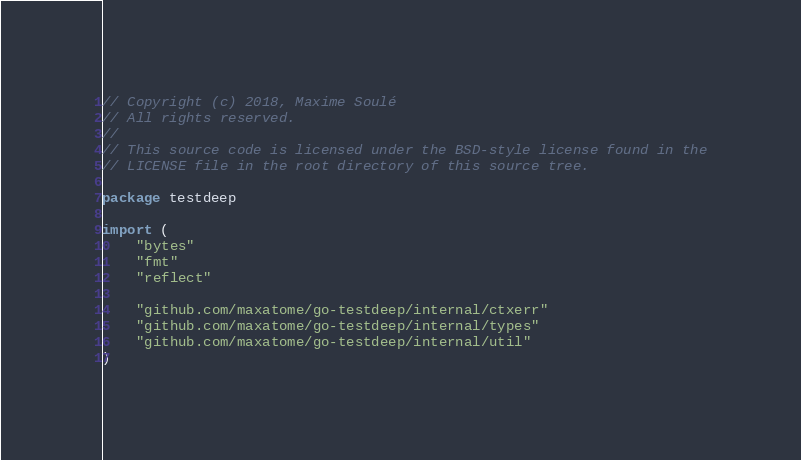<code> <loc_0><loc_0><loc_500><loc_500><_Go_>// Copyright (c) 2018, Maxime Soulé
// All rights reserved.
//
// This source code is licensed under the BSD-style license found in the
// LICENSE file in the root directory of this source tree.

package testdeep

import (
	"bytes"
	"fmt"
	"reflect"

	"github.com/maxatome/go-testdeep/internal/ctxerr"
	"github.com/maxatome/go-testdeep/internal/types"
	"github.com/maxatome/go-testdeep/internal/util"
)
</code> 